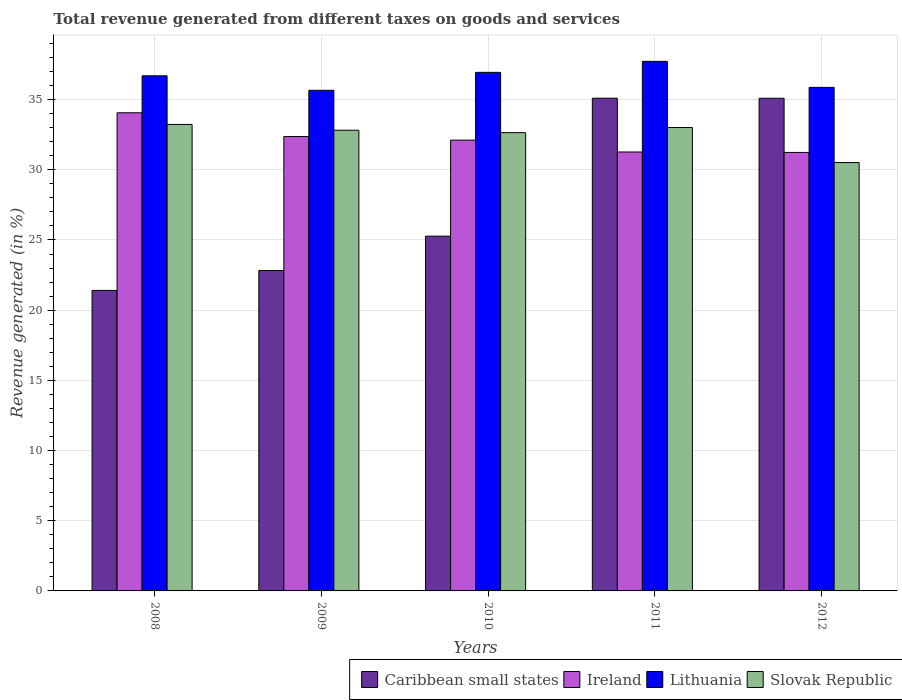What is the label of the 2nd group of bars from the left?
Ensure brevity in your answer.  2009. What is the total revenue generated in Lithuania in 2008?
Provide a succinct answer. 36.69. Across all years, what is the maximum total revenue generated in Ireland?
Your response must be concise. 34.06. Across all years, what is the minimum total revenue generated in Lithuania?
Provide a short and direct response. 35.66. What is the total total revenue generated in Ireland in the graph?
Your answer should be very brief. 161.05. What is the difference between the total revenue generated in Lithuania in 2008 and that in 2009?
Ensure brevity in your answer.  1.03. What is the difference between the total revenue generated in Ireland in 2010 and the total revenue generated in Slovak Republic in 2012?
Ensure brevity in your answer.  1.6. What is the average total revenue generated in Ireland per year?
Your answer should be compact. 32.21. In the year 2011, what is the difference between the total revenue generated in Slovak Republic and total revenue generated in Caribbean small states?
Keep it short and to the point. -2.09. What is the ratio of the total revenue generated in Ireland in 2011 to that in 2012?
Your response must be concise. 1. Is the total revenue generated in Lithuania in 2008 less than that in 2009?
Your response must be concise. No. Is the difference between the total revenue generated in Slovak Republic in 2009 and 2010 greater than the difference between the total revenue generated in Caribbean small states in 2009 and 2010?
Offer a terse response. Yes. What is the difference between the highest and the second highest total revenue generated in Lithuania?
Provide a short and direct response. 0.78. What is the difference between the highest and the lowest total revenue generated in Slovak Republic?
Give a very brief answer. 2.72. In how many years, is the total revenue generated in Slovak Republic greater than the average total revenue generated in Slovak Republic taken over all years?
Give a very brief answer. 4. What does the 2nd bar from the left in 2008 represents?
Ensure brevity in your answer.  Ireland. What does the 1st bar from the right in 2008 represents?
Your response must be concise. Slovak Republic. Is it the case that in every year, the sum of the total revenue generated in Ireland and total revenue generated in Slovak Republic is greater than the total revenue generated in Caribbean small states?
Provide a succinct answer. Yes. How many bars are there?
Your response must be concise. 20. What is the difference between two consecutive major ticks on the Y-axis?
Your answer should be compact. 5. Are the values on the major ticks of Y-axis written in scientific E-notation?
Make the answer very short. No. Does the graph contain any zero values?
Provide a succinct answer. No. Does the graph contain grids?
Make the answer very short. Yes. Where does the legend appear in the graph?
Give a very brief answer. Bottom right. How are the legend labels stacked?
Ensure brevity in your answer.  Horizontal. What is the title of the graph?
Ensure brevity in your answer.  Total revenue generated from different taxes on goods and services. Does "Qatar" appear as one of the legend labels in the graph?
Your answer should be very brief. No. What is the label or title of the X-axis?
Offer a terse response. Years. What is the label or title of the Y-axis?
Offer a terse response. Revenue generated (in %). What is the Revenue generated (in %) in Caribbean small states in 2008?
Give a very brief answer. 21.41. What is the Revenue generated (in %) of Ireland in 2008?
Keep it short and to the point. 34.06. What is the Revenue generated (in %) of Lithuania in 2008?
Offer a terse response. 36.69. What is the Revenue generated (in %) of Slovak Republic in 2008?
Offer a very short reply. 33.23. What is the Revenue generated (in %) of Caribbean small states in 2009?
Make the answer very short. 22.82. What is the Revenue generated (in %) in Ireland in 2009?
Ensure brevity in your answer.  32.37. What is the Revenue generated (in %) in Lithuania in 2009?
Give a very brief answer. 35.66. What is the Revenue generated (in %) of Slovak Republic in 2009?
Provide a succinct answer. 32.82. What is the Revenue generated (in %) in Caribbean small states in 2010?
Give a very brief answer. 25.27. What is the Revenue generated (in %) of Ireland in 2010?
Give a very brief answer. 32.11. What is the Revenue generated (in %) in Lithuania in 2010?
Your answer should be compact. 36.94. What is the Revenue generated (in %) in Slovak Republic in 2010?
Your response must be concise. 32.65. What is the Revenue generated (in %) in Caribbean small states in 2011?
Your response must be concise. 35.1. What is the Revenue generated (in %) of Ireland in 2011?
Your response must be concise. 31.27. What is the Revenue generated (in %) of Lithuania in 2011?
Provide a succinct answer. 37.72. What is the Revenue generated (in %) in Slovak Republic in 2011?
Provide a succinct answer. 33.01. What is the Revenue generated (in %) of Caribbean small states in 2012?
Your answer should be compact. 35.09. What is the Revenue generated (in %) of Ireland in 2012?
Provide a succinct answer. 31.24. What is the Revenue generated (in %) in Lithuania in 2012?
Offer a terse response. 35.87. What is the Revenue generated (in %) in Slovak Republic in 2012?
Offer a terse response. 30.51. Across all years, what is the maximum Revenue generated (in %) in Caribbean small states?
Keep it short and to the point. 35.1. Across all years, what is the maximum Revenue generated (in %) of Ireland?
Keep it short and to the point. 34.06. Across all years, what is the maximum Revenue generated (in %) of Lithuania?
Your response must be concise. 37.72. Across all years, what is the maximum Revenue generated (in %) of Slovak Republic?
Provide a short and direct response. 33.23. Across all years, what is the minimum Revenue generated (in %) of Caribbean small states?
Offer a terse response. 21.41. Across all years, what is the minimum Revenue generated (in %) of Ireland?
Ensure brevity in your answer.  31.24. Across all years, what is the minimum Revenue generated (in %) of Lithuania?
Keep it short and to the point. 35.66. Across all years, what is the minimum Revenue generated (in %) in Slovak Republic?
Ensure brevity in your answer.  30.51. What is the total Revenue generated (in %) in Caribbean small states in the graph?
Ensure brevity in your answer.  139.7. What is the total Revenue generated (in %) of Ireland in the graph?
Give a very brief answer. 161.05. What is the total Revenue generated (in %) of Lithuania in the graph?
Ensure brevity in your answer.  182.89. What is the total Revenue generated (in %) of Slovak Republic in the graph?
Ensure brevity in your answer.  162.21. What is the difference between the Revenue generated (in %) in Caribbean small states in 2008 and that in 2009?
Your answer should be compact. -1.42. What is the difference between the Revenue generated (in %) in Ireland in 2008 and that in 2009?
Offer a very short reply. 1.69. What is the difference between the Revenue generated (in %) in Lithuania in 2008 and that in 2009?
Offer a very short reply. 1.03. What is the difference between the Revenue generated (in %) of Slovak Republic in 2008 and that in 2009?
Offer a terse response. 0.41. What is the difference between the Revenue generated (in %) in Caribbean small states in 2008 and that in 2010?
Provide a succinct answer. -3.86. What is the difference between the Revenue generated (in %) of Ireland in 2008 and that in 2010?
Offer a very short reply. 1.95. What is the difference between the Revenue generated (in %) of Lithuania in 2008 and that in 2010?
Offer a very short reply. -0.24. What is the difference between the Revenue generated (in %) of Slovak Republic in 2008 and that in 2010?
Offer a terse response. 0.58. What is the difference between the Revenue generated (in %) in Caribbean small states in 2008 and that in 2011?
Your response must be concise. -13.69. What is the difference between the Revenue generated (in %) of Ireland in 2008 and that in 2011?
Provide a succinct answer. 2.79. What is the difference between the Revenue generated (in %) of Lithuania in 2008 and that in 2011?
Offer a very short reply. -1.03. What is the difference between the Revenue generated (in %) in Slovak Republic in 2008 and that in 2011?
Provide a succinct answer. 0.22. What is the difference between the Revenue generated (in %) in Caribbean small states in 2008 and that in 2012?
Offer a very short reply. -13.69. What is the difference between the Revenue generated (in %) of Ireland in 2008 and that in 2012?
Your response must be concise. 2.82. What is the difference between the Revenue generated (in %) of Lithuania in 2008 and that in 2012?
Provide a short and direct response. 0.82. What is the difference between the Revenue generated (in %) in Slovak Republic in 2008 and that in 2012?
Your answer should be very brief. 2.72. What is the difference between the Revenue generated (in %) in Caribbean small states in 2009 and that in 2010?
Give a very brief answer. -2.45. What is the difference between the Revenue generated (in %) in Ireland in 2009 and that in 2010?
Provide a succinct answer. 0.26. What is the difference between the Revenue generated (in %) of Lithuania in 2009 and that in 2010?
Provide a short and direct response. -1.28. What is the difference between the Revenue generated (in %) in Slovak Republic in 2009 and that in 2010?
Your answer should be compact. 0.17. What is the difference between the Revenue generated (in %) in Caribbean small states in 2009 and that in 2011?
Provide a short and direct response. -12.27. What is the difference between the Revenue generated (in %) in Ireland in 2009 and that in 2011?
Your answer should be compact. 1.1. What is the difference between the Revenue generated (in %) of Lithuania in 2009 and that in 2011?
Provide a succinct answer. -2.06. What is the difference between the Revenue generated (in %) of Slovak Republic in 2009 and that in 2011?
Provide a short and direct response. -0.19. What is the difference between the Revenue generated (in %) of Caribbean small states in 2009 and that in 2012?
Provide a short and direct response. -12.27. What is the difference between the Revenue generated (in %) of Ireland in 2009 and that in 2012?
Your answer should be compact. 1.13. What is the difference between the Revenue generated (in %) of Lithuania in 2009 and that in 2012?
Offer a very short reply. -0.21. What is the difference between the Revenue generated (in %) of Slovak Republic in 2009 and that in 2012?
Provide a short and direct response. 2.3. What is the difference between the Revenue generated (in %) in Caribbean small states in 2010 and that in 2011?
Provide a short and direct response. -9.83. What is the difference between the Revenue generated (in %) in Ireland in 2010 and that in 2011?
Offer a terse response. 0.85. What is the difference between the Revenue generated (in %) in Lithuania in 2010 and that in 2011?
Provide a succinct answer. -0.78. What is the difference between the Revenue generated (in %) in Slovak Republic in 2010 and that in 2011?
Give a very brief answer. -0.36. What is the difference between the Revenue generated (in %) of Caribbean small states in 2010 and that in 2012?
Offer a terse response. -9.82. What is the difference between the Revenue generated (in %) of Ireland in 2010 and that in 2012?
Keep it short and to the point. 0.88. What is the difference between the Revenue generated (in %) of Lithuania in 2010 and that in 2012?
Keep it short and to the point. 1.07. What is the difference between the Revenue generated (in %) in Slovak Republic in 2010 and that in 2012?
Keep it short and to the point. 2.13. What is the difference between the Revenue generated (in %) of Caribbean small states in 2011 and that in 2012?
Make the answer very short. 0. What is the difference between the Revenue generated (in %) in Ireland in 2011 and that in 2012?
Your response must be concise. 0.03. What is the difference between the Revenue generated (in %) in Lithuania in 2011 and that in 2012?
Give a very brief answer. 1.85. What is the difference between the Revenue generated (in %) of Slovak Republic in 2011 and that in 2012?
Your answer should be compact. 2.5. What is the difference between the Revenue generated (in %) in Caribbean small states in 2008 and the Revenue generated (in %) in Ireland in 2009?
Ensure brevity in your answer.  -10.96. What is the difference between the Revenue generated (in %) of Caribbean small states in 2008 and the Revenue generated (in %) of Lithuania in 2009?
Make the answer very short. -14.25. What is the difference between the Revenue generated (in %) of Caribbean small states in 2008 and the Revenue generated (in %) of Slovak Republic in 2009?
Ensure brevity in your answer.  -11.41. What is the difference between the Revenue generated (in %) of Ireland in 2008 and the Revenue generated (in %) of Lithuania in 2009?
Provide a succinct answer. -1.6. What is the difference between the Revenue generated (in %) in Ireland in 2008 and the Revenue generated (in %) in Slovak Republic in 2009?
Give a very brief answer. 1.24. What is the difference between the Revenue generated (in %) in Lithuania in 2008 and the Revenue generated (in %) in Slovak Republic in 2009?
Ensure brevity in your answer.  3.88. What is the difference between the Revenue generated (in %) in Caribbean small states in 2008 and the Revenue generated (in %) in Ireland in 2010?
Ensure brevity in your answer.  -10.71. What is the difference between the Revenue generated (in %) in Caribbean small states in 2008 and the Revenue generated (in %) in Lithuania in 2010?
Keep it short and to the point. -15.53. What is the difference between the Revenue generated (in %) in Caribbean small states in 2008 and the Revenue generated (in %) in Slovak Republic in 2010?
Ensure brevity in your answer.  -11.24. What is the difference between the Revenue generated (in %) in Ireland in 2008 and the Revenue generated (in %) in Lithuania in 2010?
Your answer should be compact. -2.88. What is the difference between the Revenue generated (in %) in Ireland in 2008 and the Revenue generated (in %) in Slovak Republic in 2010?
Give a very brief answer. 1.42. What is the difference between the Revenue generated (in %) in Lithuania in 2008 and the Revenue generated (in %) in Slovak Republic in 2010?
Provide a succinct answer. 4.05. What is the difference between the Revenue generated (in %) in Caribbean small states in 2008 and the Revenue generated (in %) in Ireland in 2011?
Offer a terse response. -9.86. What is the difference between the Revenue generated (in %) in Caribbean small states in 2008 and the Revenue generated (in %) in Lithuania in 2011?
Give a very brief answer. -16.32. What is the difference between the Revenue generated (in %) of Caribbean small states in 2008 and the Revenue generated (in %) of Slovak Republic in 2011?
Give a very brief answer. -11.6. What is the difference between the Revenue generated (in %) in Ireland in 2008 and the Revenue generated (in %) in Lithuania in 2011?
Offer a terse response. -3.66. What is the difference between the Revenue generated (in %) of Ireland in 2008 and the Revenue generated (in %) of Slovak Republic in 2011?
Give a very brief answer. 1.05. What is the difference between the Revenue generated (in %) of Lithuania in 2008 and the Revenue generated (in %) of Slovak Republic in 2011?
Ensure brevity in your answer.  3.68. What is the difference between the Revenue generated (in %) of Caribbean small states in 2008 and the Revenue generated (in %) of Ireland in 2012?
Give a very brief answer. -9.83. What is the difference between the Revenue generated (in %) of Caribbean small states in 2008 and the Revenue generated (in %) of Lithuania in 2012?
Provide a short and direct response. -14.46. What is the difference between the Revenue generated (in %) in Caribbean small states in 2008 and the Revenue generated (in %) in Slovak Republic in 2012?
Provide a succinct answer. -9.11. What is the difference between the Revenue generated (in %) of Ireland in 2008 and the Revenue generated (in %) of Lithuania in 2012?
Give a very brief answer. -1.81. What is the difference between the Revenue generated (in %) in Ireland in 2008 and the Revenue generated (in %) in Slovak Republic in 2012?
Offer a terse response. 3.55. What is the difference between the Revenue generated (in %) of Lithuania in 2008 and the Revenue generated (in %) of Slovak Republic in 2012?
Offer a very short reply. 6.18. What is the difference between the Revenue generated (in %) in Caribbean small states in 2009 and the Revenue generated (in %) in Ireland in 2010?
Your answer should be compact. -9.29. What is the difference between the Revenue generated (in %) of Caribbean small states in 2009 and the Revenue generated (in %) of Lithuania in 2010?
Offer a terse response. -14.11. What is the difference between the Revenue generated (in %) in Caribbean small states in 2009 and the Revenue generated (in %) in Slovak Republic in 2010?
Your response must be concise. -9.82. What is the difference between the Revenue generated (in %) in Ireland in 2009 and the Revenue generated (in %) in Lithuania in 2010?
Your response must be concise. -4.57. What is the difference between the Revenue generated (in %) of Ireland in 2009 and the Revenue generated (in %) of Slovak Republic in 2010?
Offer a very short reply. -0.28. What is the difference between the Revenue generated (in %) in Lithuania in 2009 and the Revenue generated (in %) in Slovak Republic in 2010?
Your answer should be compact. 3.02. What is the difference between the Revenue generated (in %) in Caribbean small states in 2009 and the Revenue generated (in %) in Ireland in 2011?
Give a very brief answer. -8.44. What is the difference between the Revenue generated (in %) in Caribbean small states in 2009 and the Revenue generated (in %) in Lithuania in 2011?
Make the answer very short. -14.9. What is the difference between the Revenue generated (in %) in Caribbean small states in 2009 and the Revenue generated (in %) in Slovak Republic in 2011?
Keep it short and to the point. -10.18. What is the difference between the Revenue generated (in %) in Ireland in 2009 and the Revenue generated (in %) in Lithuania in 2011?
Keep it short and to the point. -5.36. What is the difference between the Revenue generated (in %) of Ireland in 2009 and the Revenue generated (in %) of Slovak Republic in 2011?
Provide a short and direct response. -0.64. What is the difference between the Revenue generated (in %) of Lithuania in 2009 and the Revenue generated (in %) of Slovak Republic in 2011?
Ensure brevity in your answer.  2.65. What is the difference between the Revenue generated (in %) of Caribbean small states in 2009 and the Revenue generated (in %) of Ireland in 2012?
Provide a succinct answer. -8.41. What is the difference between the Revenue generated (in %) of Caribbean small states in 2009 and the Revenue generated (in %) of Lithuania in 2012?
Give a very brief answer. -13.04. What is the difference between the Revenue generated (in %) of Caribbean small states in 2009 and the Revenue generated (in %) of Slovak Republic in 2012?
Offer a very short reply. -7.69. What is the difference between the Revenue generated (in %) of Ireland in 2009 and the Revenue generated (in %) of Lithuania in 2012?
Give a very brief answer. -3.5. What is the difference between the Revenue generated (in %) of Ireland in 2009 and the Revenue generated (in %) of Slovak Republic in 2012?
Your response must be concise. 1.85. What is the difference between the Revenue generated (in %) of Lithuania in 2009 and the Revenue generated (in %) of Slovak Republic in 2012?
Your response must be concise. 5.15. What is the difference between the Revenue generated (in %) in Caribbean small states in 2010 and the Revenue generated (in %) in Ireland in 2011?
Your answer should be compact. -6. What is the difference between the Revenue generated (in %) in Caribbean small states in 2010 and the Revenue generated (in %) in Lithuania in 2011?
Your answer should be very brief. -12.45. What is the difference between the Revenue generated (in %) in Caribbean small states in 2010 and the Revenue generated (in %) in Slovak Republic in 2011?
Provide a short and direct response. -7.74. What is the difference between the Revenue generated (in %) of Ireland in 2010 and the Revenue generated (in %) of Lithuania in 2011?
Offer a terse response. -5.61. What is the difference between the Revenue generated (in %) in Ireland in 2010 and the Revenue generated (in %) in Slovak Republic in 2011?
Your response must be concise. -0.9. What is the difference between the Revenue generated (in %) in Lithuania in 2010 and the Revenue generated (in %) in Slovak Republic in 2011?
Offer a very short reply. 3.93. What is the difference between the Revenue generated (in %) in Caribbean small states in 2010 and the Revenue generated (in %) in Ireland in 2012?
Provide a short and direct response. -5.97. What is the difference between the Revenue generated (in %) in Caribbean small states in 2010 and the Revenue generated (in %) in Lithuania in 2012?
Provide a short and direct response. -10.6. What is the difference between the Revenue generated (in %) of Caribbean small states in 2010 and the Revenue generated (in %) of Slovak Republic in 2012?
Provide a short and direct response. -5.24. What is the difference between the Revenue generated (in %) in Ireland in 2010 and the Revenue generated (in %) in Lithuania in 2012?
Make the answer very short. -3.76. What is the difference between the Revenue generated (in %) of Ireland in 2010 and the Revenue generated (in %) of Slovak Republic in 2012?
Offer a terse response. 1.6. What is the difference between the Revenue generated (in %) in Lithuania in 2010 and the Revenue generated (in %) in Slovak Republic in 2012?
Your answer should be very brief. 6.43. What is the difference between the Revenue generated (in %) of Caribbean small states in 2011 and the Revenue generated (in %) of Ireland in 2012?
Offer a very short reply. 3.86. What is the difference between the Revenue generated (in %) of Caribbean small states in 2011 and the Revenue generated (in %) of Lithuania in 2012?
Offer a terse response. -0.77. What is the difference between the Revenue generated (in %) of Caribbean small states in 2011 and the Revenue generated (in %) of Slovak Republic in 2012?
Keep it short and to the point. 4.58. What is the difference between the Revenue generated (in %) of Ireland in 2011 and the Revenue generated (in %) of Lithuania in 2012?
Give a very brief answer. -4.6. What is the difference between the Revenue generated (in %) in Ireland in 2011 and the Revenue generated (in %) in Slovak Republic in 2012?
Your response must be concise. 0.75. What is the difference between the Revenue generated (in %) of Lithuania in 2011 and the Revenue generated (in %) of Slovak Republic in 2012?
Give a very brief answer. 7.21. What is the average Revenue generated (in %) of Caribbean small states per year?
Your answer should be very brief. 27.94. What is the average Revenue generated (in %) in Ireland per year?
Your answer should be very brief. 32.21. What is the average Revenue generated (in %) of Lithuania per year?
Your response must be concise. 36.58. What is the average Revenue generated (in %) in Slovak Republic per year?
Your answer should be compact. 32.44. In the year 2008, what is the difference between the Revenue generated (in %) in Caribbean small states and Revenue generated (in %) in Ireland?
Offer a very short reply. -12.65. In the year 2008, what is the difference between the Revenue generated (in %) of Caribbean small states and Revenue generated (in %) of Lithuania?
Provide a short and direct response. -15.29. In the year 2008, what is the difference between the Revenue generated (in %) in Caribbean small states and Revenue generated (in %) in Slovak Republic?
Ensure brevity in your answer.  -11.82. In the year 2008, what is the difference between the Revenue generated (in %) of Ireland and Revenue generated (in %) of Lithuania?
Your answer should be very brief. -2.63. In the year 2008, what is the difference between the Revenue generated (in %) of Ireland and Revenue generated (in %) of Slovak Republic?
Provide a short and direct response. 0.83. In the year 2008, what is the difference between the Revenue generated (in %) of Lithuania and Revenue generated (in %) of Slovak Republic?
Provide a succinct answer. 3.47. In the year 2009, what is the difference between the Revenue generated (in %) of Caribbean small states and Revenue generated (in %) of Ireland?
Ensure brevity in your answer.  -9.54. In the year 2009, what is the difference between the Revenue generated (in %) in Caribbean small states and Revenue generated (in %) in Lithuania?
Make the answer very short. -12.84. In the year 2009, what is the difference between the Revenue generated (in %) in Caribbean small states and Revenue generated (in %) in Slovak Republic?
Offer a very short reply. -9.99. In the year 2009, what is the difference between the Revenue generated (in %) of Ireland and Revenue generated (in %) of Lithuania?
Keep it short and to the point. -3.29. In the year 2009, what is the difference between the Revenue generated (in %) in Ireland and Revenue generated (in %) in Slovak Republic?
Your answer should be compact. -0.45. In the year 2009, what is the difference between the Revenue generated (in %) in Lithuania and Revenue generated (in %) in Slovak Republic?
Keep it short and to the point. 2.84. In the year 2010, what is the difference between the Revenue generated (in %) of Caribbean small states and Revenue generated (in %) of Ireland?
Offer a very short reply. -6.84. In the year 2010, what is the difference between the Revenue generated (in %) of Caribbean small states and Revenue generated (in %) of Lithuania?
Provide a short and direct response. -11.67. In the year 2010, what is the difference between the Revenue generated (in %) in Caribbean small states and Revenue generated (in %) in Slovak Republic?
Offer a terse response. -7.37. In the year 2010, what is the difference between the Revenue generated (in %) of Ireland and Revenue generated (in %) of Lithuania?
Your answer should be very brief. -4.83. In the year 2010, what is the difference between the Revenue generated (in %) in Ireland and Revenue generated (in %) in Slovak Republic?
Provide a short and direct response. -0.53. In the year 2010, what is the difference between the Revenue generated (in %) in Lithuania and Revenue generated (in %) in Slovak Republic?
Your response must be concise. 4.29. In the year 2011, what is the difference between the Revenue generated (in %) in Caribbean small states and Revenue generated (in %) in Ireland?
Ensure brevity in your answer.  3.83. In the year 2011, what is the difference between the Revenue generated (in %) in Caribbean small states and Revenue generated (in %) in Lithuania?
Your answer should be very brief. -2.63. In the year 2011, what is the difference between the Revenue generated (in %) in Caribbean small states and Revenue generated (in %) in Slovak Republic?
Give a very brief answer. 2.09. In the year 2011, what is the difference between the Revenue generated (in %) in Ireland and Revenue generated (in %) in Lithuania?
Make the answer very short. -6.46. In the year 2011, what is the difference between the Revenue generated (in %) in Ireland and Revenue generated (in %) in Slovak Republic?
Keep it short and to the point. -1.74. In the year 2011, what is the difference between the Revenue generated (in %) in Lithuania and Revenue generated (in %) in Slovak Republic?
Offer a very short reply. 4.71. In the year 2012, what is the difference between the Revenue generated (in %) in Caribbean small states and Revenue generated (in %) in Ireland?
Keep it short and to the point. 3.86. In the year 2012, what is the difference between the Revenue generated (in %) of Caribbean small states and Revenue generated (in %) of Lithuania?
Make the answer very short. -0.78. In the year 2012, what is the difference between the Revenue generated (in %) in Caribbean small states and Revenue generated (in %) in Slovak Republic?
Offer a terse response. 4.58. In the year 2012, what is the difference between the Revenue generated (in %) in Ireland and Revenue generated (in %) in Lithuania?
Your response must be concise. -4.63. In the year 2012, what is the difference between the Revenue generated (in %) of Ireland and Revenue generated (in %) of Slovak Republic?
Your answer should be very brief. 0.72. In the year 2012, what is the difference between the Revenue generated (in %) of Lithuania and Revenue generated (in %) of Slovak Republic?
Your response must be concise. 5.36. What is the ratio of the Revenue generated (in %) in Caribbean small states in 2008 to that in 2009?
Provide a succinct answer. 0.94. What is the ratio of the Revenue generated (in %) in Ireland in 2008 to that in 2009?
Your answer should be very brief. 1.05. What is the ratio of the Revenue generated (in %) in Lithuania in 2008 to that in 2009?
Provide a short and direct response. 1.03. What is the ratio of the Revenue generated (in %) of Slovak Republic in 2008 to that in 2009?
Offer a very short reply. 1.01. What is the ratio of the Revenue generated (in %) in Caribbean small states in 2008 to that in 2010?
Your answer should be very brief. 0.85. What is the ratio of the Revenue generated (in %) of Ireland in 2008 to that in 2010?
Offer a terse response. 1.06. What is the ratio of the Revenue generated (in %) of Slovak Republic in 2008 to that in 2010?
Offer a terse response. 1.02. What is the ratio of the Revenue generated (in %) of Caribbean small states in 2008 to that in 2011?
Offer a terse response. 0.61. What is the ratio of the Revenue generated (in %) in Ireland in 2008 to that in 2011?
Offer a terse response. 1.09. What is the ratio of the Revenue generated (in %) in Lithuania in 2008 to that in 2011?
Provide a short and direct response. 0.97. What is the ratio of the Revenue generated (in %) in Caribbean small states in 2008 to that in 2012?
Ensure brevity in your answer.  0.61. What is the ratio of the Revenue generated (in %) of Ireland in 2008 to that in 2012?
Offer a very short reply. 1.09. What is the ratio of the Revenue generated (in %) of Lithuania in 2008 to that in 2012?
Make the answer very short. 1.02. What is the ratio of the Revenue generated (in %) in Slovak Republic in 2008 to that in 2012?
Your answer should be compact. 1.09. What is the ratio of the Revenue generated (in %) of Caribbean small states in 2009 to that in 2010?
Offer a terse response. 0.9. What is the ratio of the Revenue generated (in %) in Ireland in 2009 to that in 2010?
Offer a very short reply. 1.01. What is the ratio of the Revenue generated (in %) in Lithuania in 2009 to that in 2010?
Offer a very short reply. 0.97. What is the ratio of the Revenue generated (in %) in Slovak Republic in 2009 to that in 2010?
Give a very brief answer. 1.01. What is the ratio of the Revenue generated (in %) of Caribbean small states in 2009 to that in 2011?
Make the answer very short. 0.65. What is the ratio of the Revenue generated (in %) of Ireland in 2009 to that in 2011?
Make the answer very short. 1.04. What is the ratio of the Revenue generated (in %) in Lithuania in 2009 to that in 2011?
Your answer should be compact. 0.95. What is the ratio of the Revenue generated (in %) in Caribbean small states in 2009 to that in 2012?
Make the answer very short. 0.65. What is the ratio of the Revenue generated (in %) in Ireland in 2009 to that in 2012?
Your answer should be compact. 1.04. What is the ratio of the Revenue generated (in %) in Slovak Republic in 2009 to that in 2012?
Ensure brevity in your answer.  1.08. What is the ratio of the Revenue generated (in %) in Caribbean small states in 2010 to that in 2011?
Offer a very short reply. 0.72. What is the ratio of the Revenue generated (in %) in Lithuania in 2010 to that in 2011?
Your response must be concise. 0.98. What is the ratio of the Revenue generated (in %) in Slovak Republic in 2010 to that in 2011?
Your response must be concise. 0.99. What is the ratio of the Revenue generated (in %) of Caribbean small states in 2010 to that in 2012?
Keep it short and to the point. 0.72. What is the ratio of the Revenue generated (in %) of Ireland in 2010 to that in 2012?
Keep it short and to the point. 1.03. What is the ratio of the Revenue generated (in %) of Lithuania in 2010 to that in 2012?
Keep it short and to the point. 1.03. What is the ratio of the Revenue generated (in %) of Slovak Republic in 2010 to that in 2012?
Your answer should be very brief. 1.07. What is the ratio of the Revenue generated (in %) in Caribbean small states in 2011 to that in 2012?
Offer a terse response. 1. What is the ratio of the Revenue generated (in %) in Lithuania in 2011 to that in 2012?
Make the answer very short. 1.05. What is the ratio of the Revenue generated (in %) of Slovak Republic in 2011 to that in 2012?
Keep it short and to the point. 1.08. What is the difference between the highest and the second highest Revenue generated (in %) in Caribbean small states?
Ensure brevity in your answer.  0. What is the difference between the highest and the second highest Revenue generated (in %) of Ireland?
Ensure brevity in your answer.  1.69. What is the difference between the highest and the second highest Revenue generated (in %) in Lithuania?
Offer a very short reply. 0.78. What is the difference between the highest and the second highest Revenue generated (in %) of Slovak Republic?
Keep it short and to the point. 0.22. What is the difference between the highest and the lowest Revenue generated (in %) of Caribbean small states?
Offer a very short reply. 13.69. What is the difference between the highest and the lowest Revenue generated (in %) of Ireland?
Offer a very short reply. 2.82. What is the difference between the highest and the lowest Revenue generated (in %) in Lithuania?
Provide a succinct answer. 2.06. What is the difference between the highest and the lowest Revenue generated (in %) in Slovak Republic?
Your response must be concise. 2.72. 